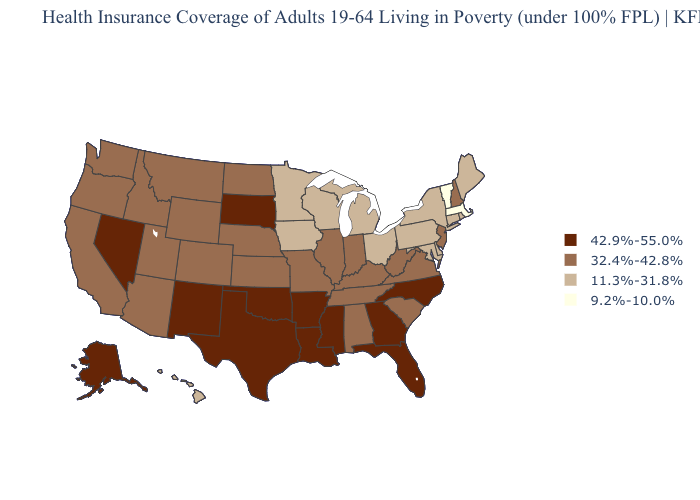Does Nevada have the highest value in the USA?
Quick response, please. Yes. Name the states that have a value in the range 32.4%-42.8%?
Concise answer only. Alabama, Arizona, California, Colorado, Idaho, Illinois, Indiana, Kansas, Kentucky, Missouri, Montana, Nebraska, New Hampshire, New Jersey, North Dakota, Oregon, South Carolina, Tennessee, Utah, Virginia, Washington, West Virginia, Wyoming. What is the value of Hawaii?
Short answer required. 11.3%-31.8%. Does Vermont have the lowest value in the USA?
Concise answer only. Yes. Name the states that have a value in the range 32.4%-42.8%?
Be succinct. Alabama, Arizona, California, Colorado, Idaho, Illinois, Indiana, Kansas, Kentucky, Missouri, Montana, Nebraska, New Hampshire, New Jersey, North Dakota, Oregon, South Carolina, Tennessee, Utah, Virginia, Washington, West Virginia, Wyoming. What is the value of West Virginia?
Write a very short answer. 32.4%-42.8%. Among the states that border Oklahoma , which have the highest value?
Be succinct. Arkansas, New Mexico, Texas. What is the value of Kentucky?
Answer briefly. 32.4%-42.8%. Name the states that have a value in the range 42.9%-55.0%?
Give a very brief answer. Alaska, Arkansas, Florida, Georgia, Louisiana, Mississippi, Nevada, New Mexico, North Carolina, Oklahoma, South Dakota, Texas. Does West Virginia have a higher value than Montana?
Answer briefly. No. What is the lowest value in the South?
Answer briefly. 11.3%-31.8%. Among the states that border Maine , which have the lowest value?
Answer briefly. New Hampshire. Name the states that have a value in the range 9.2%-10.0%?
Write a very short answer. Massachusetts, Vermont. What is the lowest value in states that border Ohio?
Quick response, please. 11.3%-31.8%. 